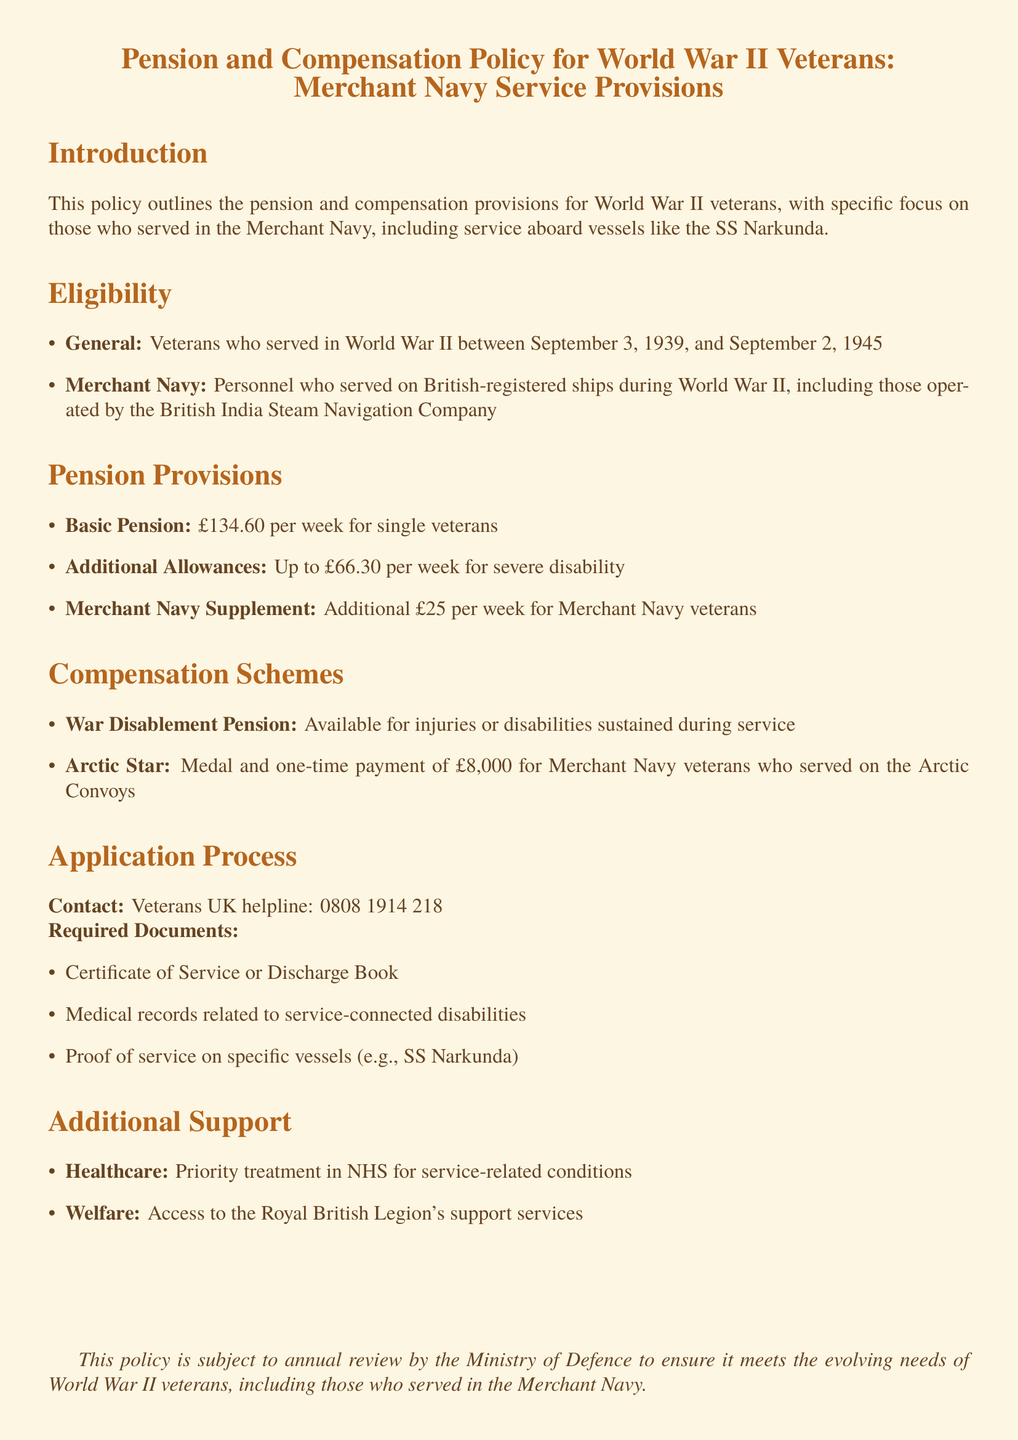What is the basic pension amount for single veterans? The basic pension amount is mentioned in the pension provisions section as £134.60 per week.
Answer: £134.60 What is the additional allowance for severe disability? The document specifies that the additional allowance for severe disability is up to £66.30 per week.
Answer: £66.30 Who is eligible for the Merchant Navy supplement? The document states that personnel who served on British-registered ships during World War II are eligible for the Merchant Navy supplement.
Answer: Personnel who served on British-registered ships What is the one-time payment for Merchant Navy veterans who served on the Arctic Convoys? The one-time payment specified in the compensation schemes section is £8,000.
Answer: £8,000 Which document is required to prove service on specific vessels? The required document for this purpose, as listed in the application process section, is proof of service on specific vessels.
Answer: Proof of service on specific vessels What is the contact number for the Veterans UK helpline? The document provides the contact number for the Veterans UK helpline as 0808 1914 218.
Answer: 0808 1914 218 What type of healthcare support is provided to veterans? The type of healthcare support mentioned is priority treatment in NHS for service-related conditions.
Answer: Priority treatment in NHS What annual action is taken regarding the policy? The document states that this policy is subject to annual review by the Ministry of Defence.
Answer: Annual review What additional support service is mentioned for veterans? The document mentions access to the Royal British Legion's support services as an additional support service.
Answer: Royal British Legion's support services 